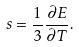<formula> <loc_0><loc_0><loc_500><loc_500>s = \frac { 1 } { 3 } \frac { \partial E } { \partial T } .</formula> 